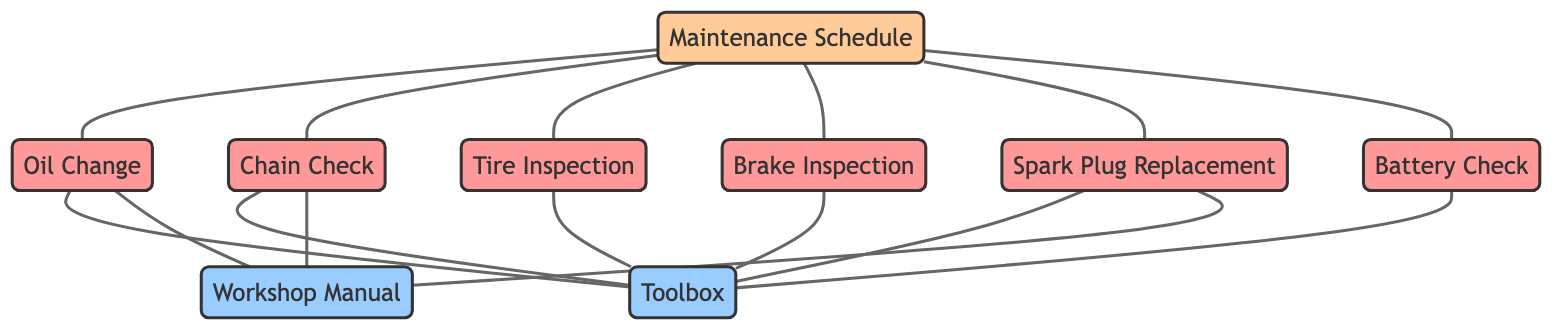What is the total number of nodes in the diagram? The diagram contains a set of nodes listed in the provided data. By counting them, we find there are 9 nodes: Chain Check, Oil Change, Tire Inspection, Brake Inspection, Spark Plug Replacement, Battery Check, Maintenance Schedule, Toolbox, and Workshop Manual.
Answer: 9 Which task is connected to the Toolbox? The edges connecting to the toolbox indicate the tasks that require it. From the diagram, the tasks connected to Toolbox are Chain Check, Oil Change, Tire Inspection, Brake Inspection, Spark Plug Replacement, and Battery Check.
Answer: Six tasks What tools are linked to the Spark Plug Replacement? The diagram shows that Spark Plug Replacement has edges connecting to the Toolbox and the Workshop Manual. This indicates that both these tools are relevant for the task of Spark Plug Replacement.
Answer: Toolbox and Workshop Manual How many maintenance tasks are scheduled under the Maintenance Schedule? The edges from the Maintenance Schedule node show direct connections to the maintenance tasks: Oil Change, Chain Check, Tire Inspection, Brake Inspection, Spark Plug Replacement, and Battery Check. Counting these gives us a total of six tasks.
Answer: Six tasks Which maintenance tasks do not require the Workshop Manual? By observing the connections, we see that both battery check and toolbox are not connected to the workshop manual. Meanwhile, tasks like Oil Change, Chain Check, Tire Inspection, Brake Inspection, and Spark Plug Replacement are all connected to the Workshop Manual, suggesting they require it. The only task left that doesn't require the workshop manual is Battery Check.
Answer: Battery Check How many edges are there connecting tasks to the Toolbox? By examining the connections leading to the Toolbox node, there are a total of six edges connecting tasks (Chain Check, Oil Change, Tire Inspection, Brake Inspection, Spark Plug Replacement, and Battery Check) to the Toolbox. This counts the direct connections from the tasks to the Toolbox.
Answer: Six edges What is the relationship between the Maintenance Schedule and the Oil Change? The diagram shows a direct edge from Maintenance Schedule to Oil Change, indicating that Oil Change is part of the scheduled maintenance tasks, and thus it is derived from the Maintenance Schedule.
Answer: Direct connection Which tool is required for the Tire Inspection? The edge from Tire Inspection to Toolbox indicates that the Toolbox is necessary for performing the Tire Inspection, signifying the need for tools located within it.
Answer: Toolbox 